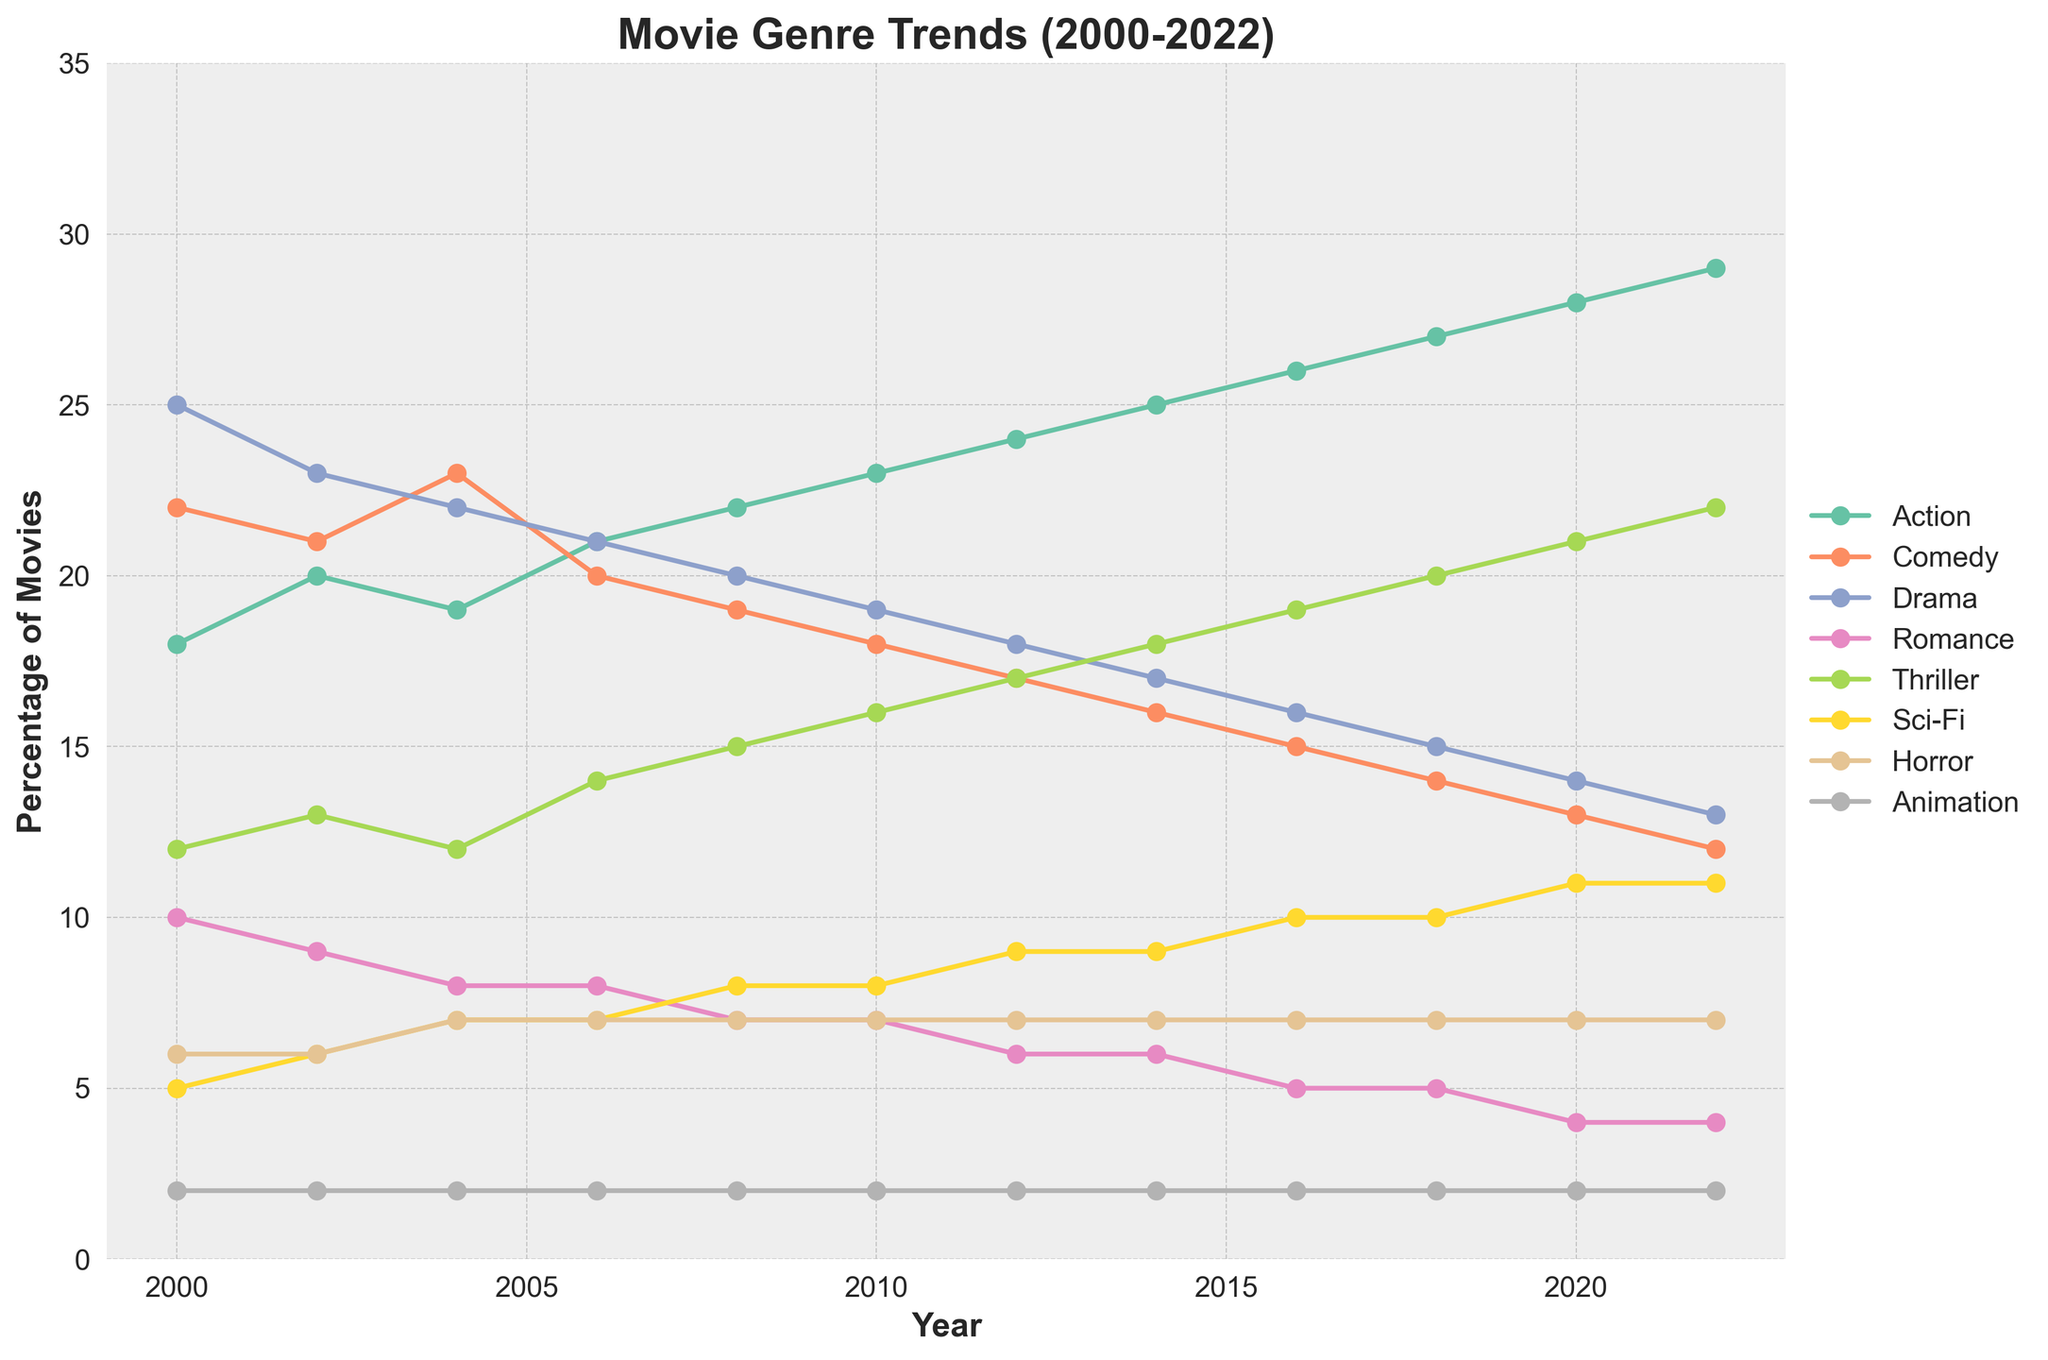What genre had the highest percentage in 2000? By looking at the figure, we can identify the line that peaks the highest in the year 2000. The genre with the highest percentage in that year is represented by this line.
Answer: Drama How has the percentage of Romance movies changed from 2000 to 2022? By locating the points for Romance movies in 2000 and 2022 on the figure, we can see how much it has decreased or increased. The percentage has decreased from 10% in 2000 to 4% in 2022.
Answer: Decreased Between 2008 and 2018, which genre showed the most increase in percentage? By comparing the points between 2008 and 2018 for all genres, we can determine which genre line has moved upwards the most. Thriller increased from 15% to 20%.
Answer: Thriller Which genre had the most stable percentage trend from 2000 to 2022? Using the figure, we seek for the genre line that shows the least amount of fluctuation over the years. Horror genre line remains relatively flat, hovering around 7%.
Answer: Horror In what year did Action movies start to become the dominant genre? By following the Action genre line from 2000 onwards and identifying the year it first exceeds the rest, we can pinpoint when it became dominant. Action movies become the dominant genre in 2012.
Answer: 2012 What is the combined percentage for Comedy and Sci-Fi in 2022? Locate the percentage values for Comedy and Sci-Fi in 2022 from the graph, and add them together (12% + 11%).
Answer: 23% Which year saw the highest percentage of Thriller movies? By identifying the peak point on the Thriller genre line on the graph, we can find the year that corresponds to this peak. The highest percentage for Thriller movies is in 2022.
Answer: 2022 How does the percentage of Action movies in 2020 compare to that in 2000? Compare the points on the Action genre line for the years 2000 and 2020 from the figure. Action movies increased from 18% in 2000 to 28% in 2020.
Answer: Increased What is the average percentage of Drama movies from 2000 to 2022? Sum the percentages of Drama movies for each year shown in the graph, then divide by the number of years (23). Calculate as follows: (25 + 23 + 22 + 21 + 20 + 19 + 18 + 17 + 16 + 15 + 14 + 13) / 12.
Answer: 18.5% Which two genres had equal percentages in 2006? Identify the year 2006 on the figure and locate two genre lines that intersect or have the same percentage value. Comedy and Drama both had 20%.
Answer: Comedy and Drama 